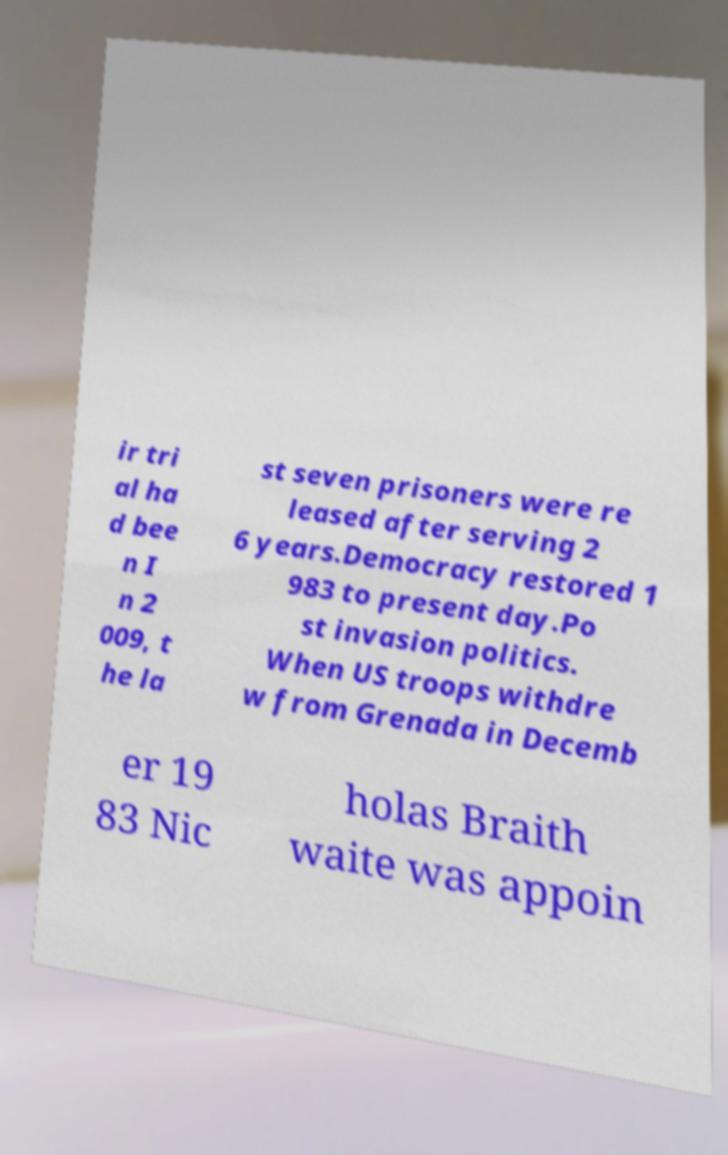Can you accurately transcribe the text from the provided image for me? ir tri al ha d bee n I n 2 009, t he la st seven prisoners were re leased after serving 2 6 years.Democracy restored 1 983 to present day.Po st invasion politics. When US troops withdre w from Grenada in Decemb er 19 83 Nic holas Braith waite was appoin 